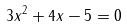Convert formula to latex. <formula><loc_0><loc_0><loc_500><loc_500>3 x ^ { 2 } + 4 x - 5 = 0</formula> 